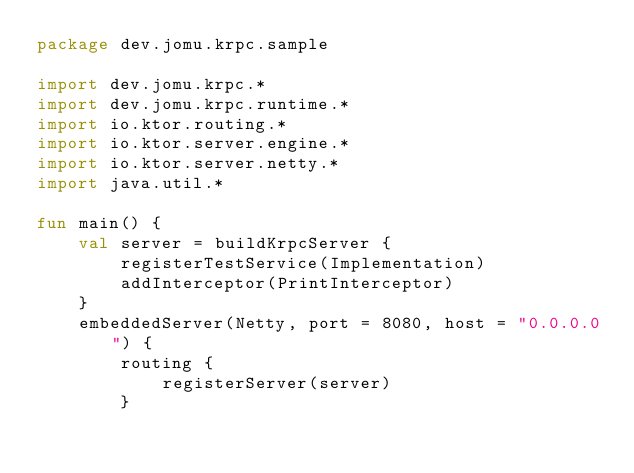<code> <loc_0><loc_0><loc_500><loc_500><_Kotlin_>package dev.jomu.krpc.sample

import dev.jomu.krpc.*
import dev.jomu.krpc.runtime.*
import io.ktor.routing.*
import io.ktor.server.engine.*
import io.ktor.server.netty.*
import java.util.*

fun main() {
    val server = buildKrpcServer {
        registerTestService(Implementation)
        addInterceptor(PrintInterceptor)
    }
    embeddedServer(Netty, port = 8080, host = "0.0.0.0") {
        routing {
            registerServer(server)
        }</code> 